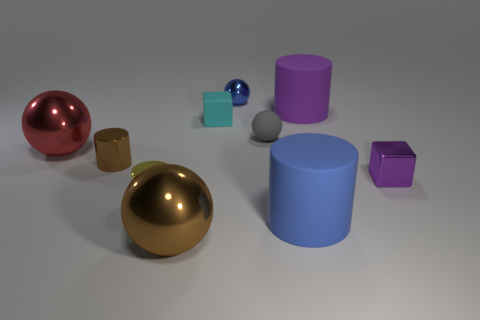Subtract all cylinders. How many objects are left? 6 Add 6 small blue objects. How many small blue objects are left? 7 Add 1 cylinders. How many cylinders exist? 5 Subtract 1 purple cylinders. How many objects are left? 9 Subtract all blue shiny things. Subtract all tiny cyan matte things. How many objects are left? 8 